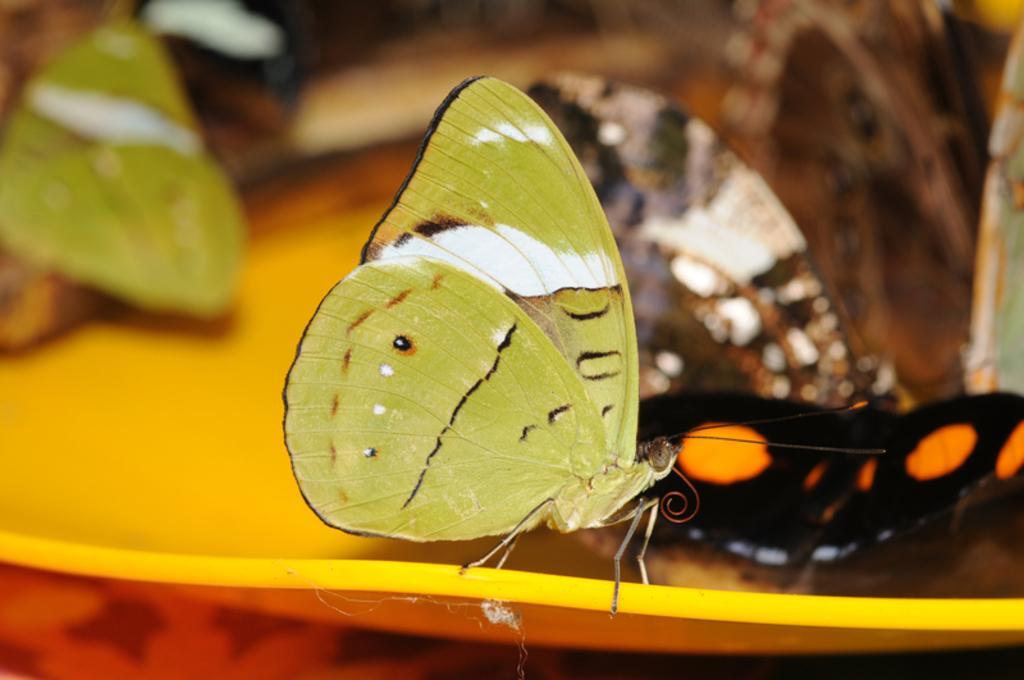Describe this image in one or two sentences. In this image I can see two butterflies, the butterfly in front is in green and white color and the butterfly at right is in black and orange color, and I can see blurred background. 